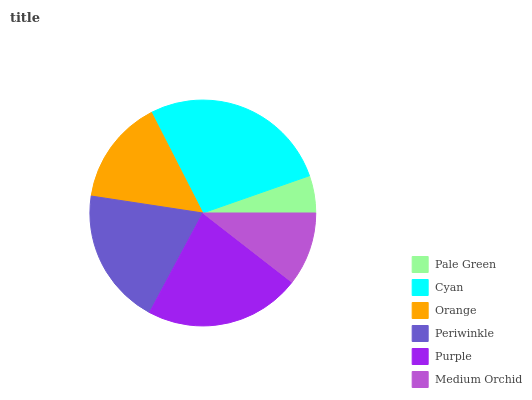Is Pale Green the minimum?
Answer yes or no. Yes. Is Cyan the maximum?
Answer yes or no. Yes. Is Orange the minimum?
Answer yes or no. No. Is Orange the maximum?
Answer yes or no. No. Is Cyan greater than Orange?
Answer yes or no. Yes. Is Orange less than Cyan?
Answer yes or no. Yes. Is Orange greater than Cyan?
Answer yes or no. No. Is Cyan less than Orange?
Answer yes or no. No. Is Periwinkle the high median?
Answer yes or no. Yes. Is Orange the low median?
Answer yes or no. Yes. Is Orange the high median?
Answer yes or no. No. Is Periwinkle the low median?
Answer yes or no. No. 